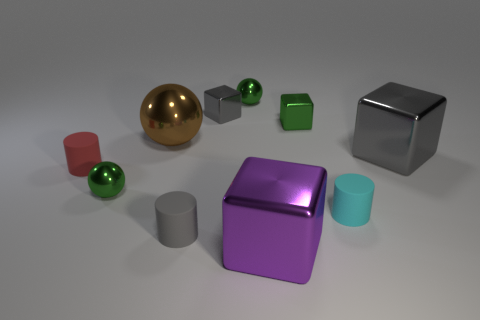Subtract all small green metallic cubes. How many cubes are left? 3 Subtract all blue blocks. How many green spheres are left? 2 Subtract 2 cylinders. How many cylinders are left? 1 Subtract all gray cylinders. How many cylinders are left? 2 Subtract all blocks. How many objects are left? 6 Subtract all red cylinders. Subtract all blue cubes. How many cylinders are left? 2 Subtract all large gray metal objects. Subtract all large green rubber cylinders. How many objects are left? 9 Add 1 small green spheres. How many small green spheres are left? 3 Add 7 large brown spheres. How many large brown spheres exist? 8 Subtract 0 yellow balls. How many objects are left? 10 